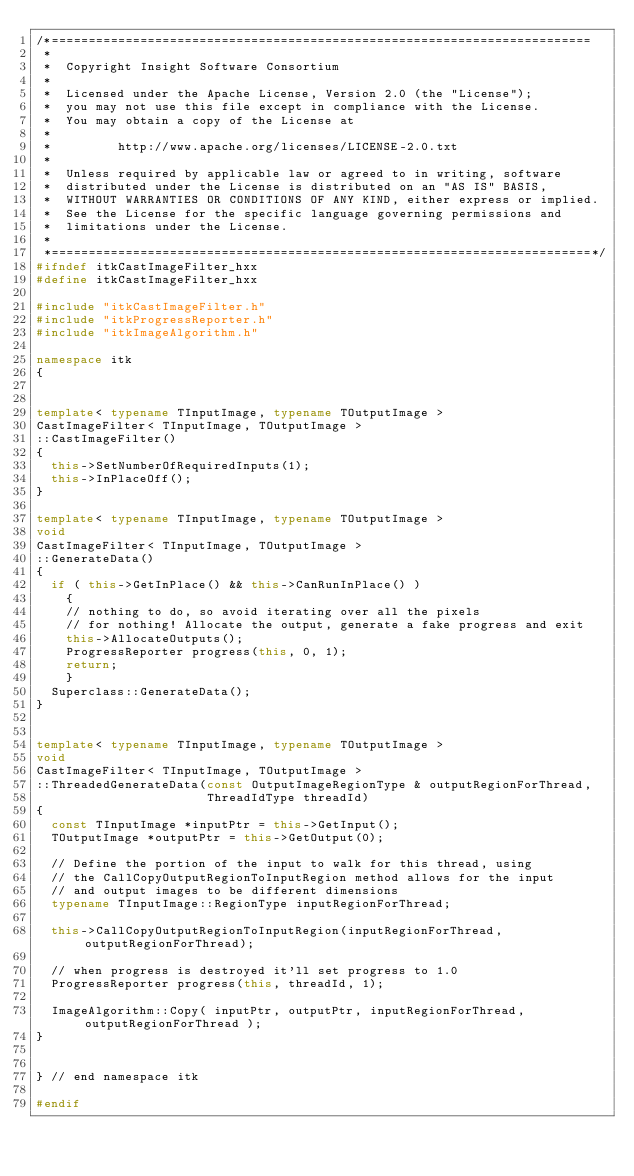<code> <loc_0><loc_0><loc_500><loc_500><_C++_>/*=========================================================================
 *
 *  Copyright Insight Software Consortium
 *
 *  Licensed under the Apache License, Version 2.0 (the "License");
 *  you may not use this file except in compliance with the License.
 *  You may obtain a copy of the License at
 *
 *         http://www.apache.org/licenses/LICENSE-2.0.txt
 *
 *  Unless required by applicable law or agreed to in writing, software
 *  distributed under the License is distributed on an "AS IS" BASIS,
 *  WITHOUT WARRANTIES OR CONDITIONS OF ANY KIND, either express or implied.
 *  See the License for the specific language governing permissions and
 *  limitations under the License.
 *
 *=========================================================================*/
#ifndef itkCastImageFilter_hxx
#define itkCastImageFilter_hxx

#include "itkCastImageFilter.h"
#include "itkProgressReporter.h"
#include "itkImageAlgorithm.h"

namespace itk
{


template< typename TInputImage, typename TOutputImage >
CastImageFilter< TInputImage, TOutputImage >
::CastImageFilter()
{
  this->SetNumberOfRequiredInputs(1);
  this->InPlaceOff();
}

template< typename TInputImage, typename TOutputImage >
void
CastImageFilter< TInputImage, TOutputImage >
::GenerateData()
{
  if ( this->GetInPlace() && this->CanRunInPlace() )
    {
    // nothing to do, so avoid iterating over all the pixels
    // for nothing! Allocate the output, generate a fake progress and exit
    this->AllocateOutputs();
    ProgressReporter progress(this, 0, 1);
    return;
    }
  Superclass::GenerateData();
}


template< typename TInputImage, typename TOutputImage >
void
CastImageFilter< TInputImage, TOutputImage >
::ThreadedGenerateData(const OutputImageRegionType & outputRegionForThread,
                       ThreadIdType threadId)
{
  const TInputImage *inputPtr = this->GetInput();
  TOutputImage *outputPtr = this->GetOutput(0);

  // Define the portion of the input to walk for this thread, using
  // the CallCopyOutputRegionToInputRegion method allows for the input
  // and output images to be different dimensions
  typename TInputImage::RegionType inputRegionForThread;

  this->CallCopyOutputRegionToInputRegion(inputRegionForThread, outputRegionForThread);

  // when progress is destroyed it'll set progress to 1.0
  ProgressReporter progress(this, threadId, 1);

  ImageAlgorithm::Copy( inputPtr, outputPtr, inputRegionForThread, outputRegionForThread );
}


} // end namespace itk

#endif
</code> 